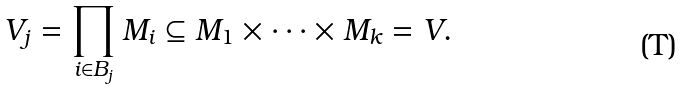<formula> <loc_0><loc_0><loc_500><loc_500>V _ { j } = \prod _ { i \in B _ { j } } M _ { i } \subseteq M _ { 1 } \times \cdots \times M _ { k } = V .</formula> 